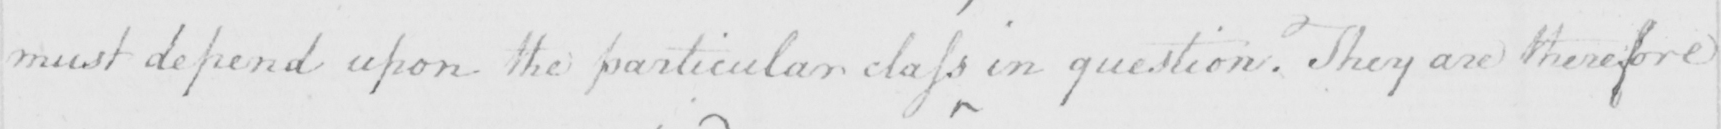What is written in this line of handwriting? must depend upon the particular class in question . They are therefore 